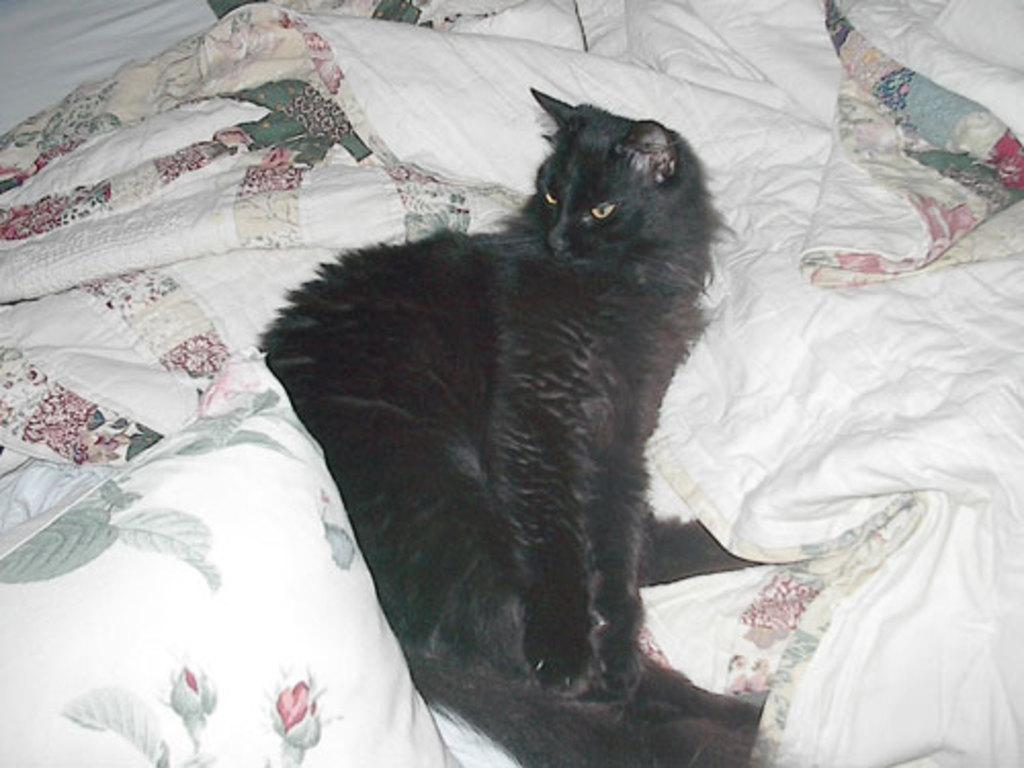What type of animal is in the image? There is a black cat in the image. What is the cat sitting on? The black cat is sitting on a white bed sheet. What type of locket is the black cat wearing around its neck in the image? There is no locket visible around the black cat's neck in the image. What is the black cat eating from a straw in the image? There is no straw or food present in the image; the black cat is simply sitting on a white bed sheet. 